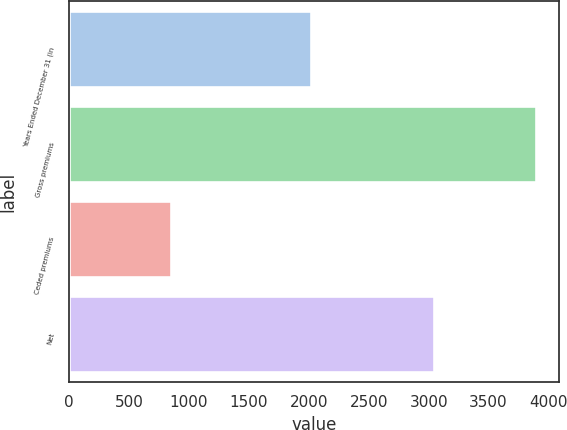<chart> <loc_0><loc_0><loc_500><loc_500><bar_chart><fcel>Years Ended December 31 (in<fcel>Gross premiums<fcel>Ceded premiums<fcel>Net<nl><fcel>2018<fcel>3893<fcel>850<fcel>3043<nl></chart> 